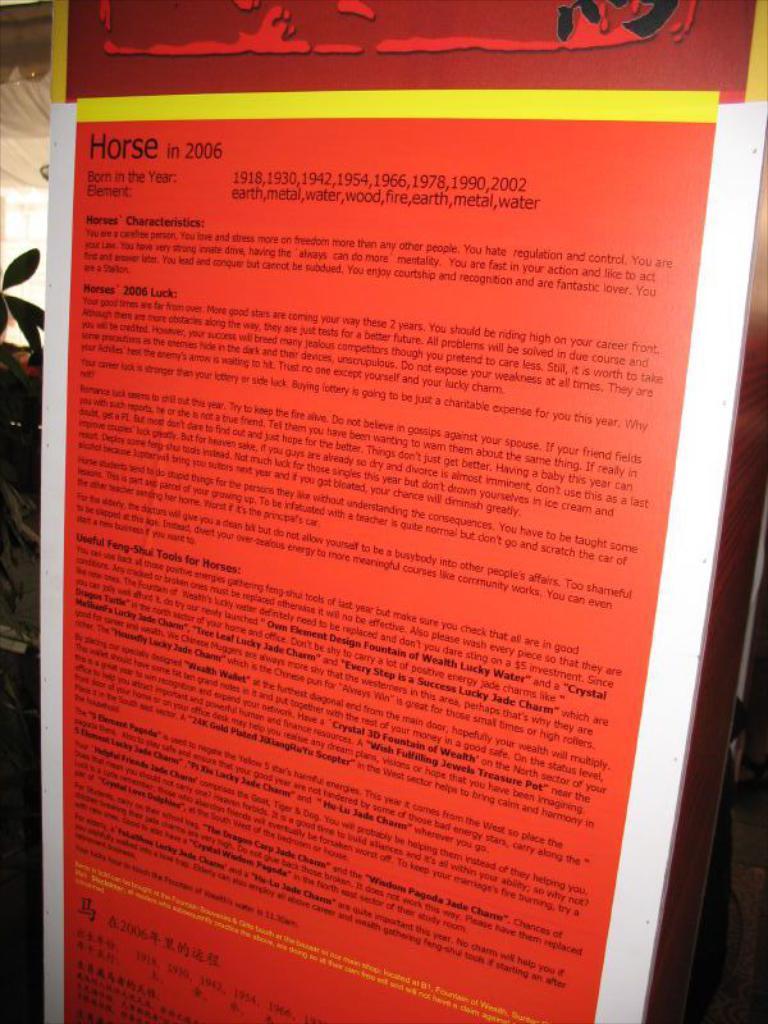What was in 2006?
Offer a very short reply. Horse. 